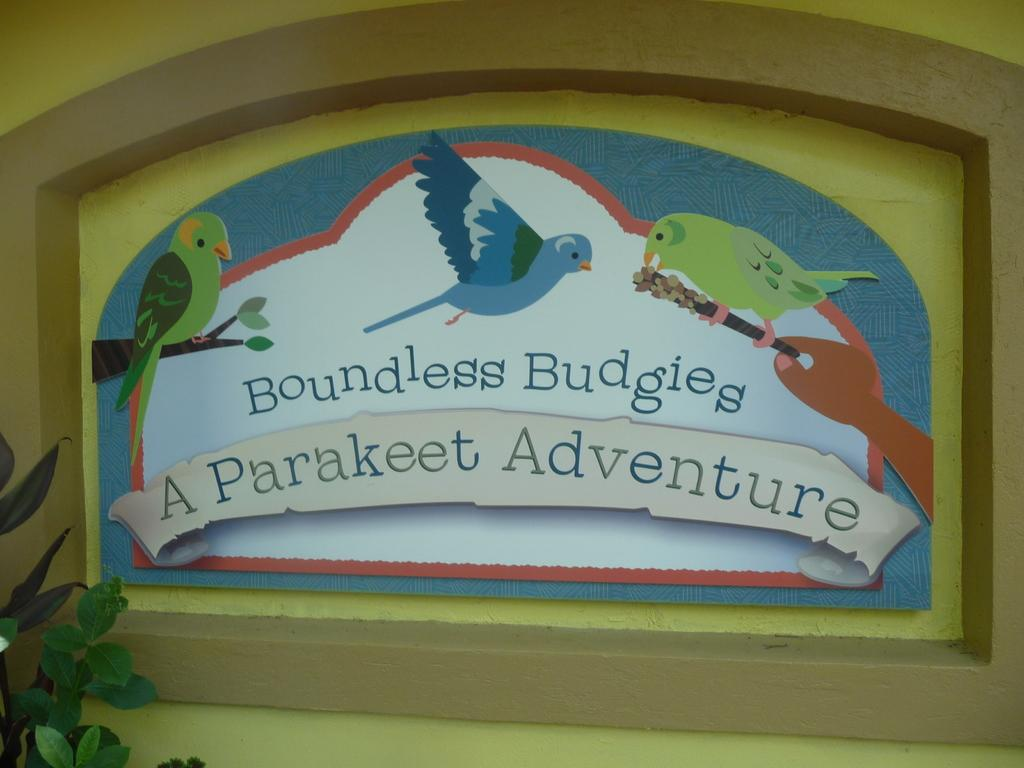What is depicted on the painting that is on the wall in the image? There is a painting of birds on the wall in the image. What else can be seen on the wall besides the painting? There is text on the wall in the image. What type of vegetation is in front of the wall? There is a plant in front of the wall in the image. How many points does the plant have in the image? The plant does not have points; it is a living organism with leaves and stems. What direction does the text on the wall turn in the image? The text on the wall does not turn; it is stationary and readable. 